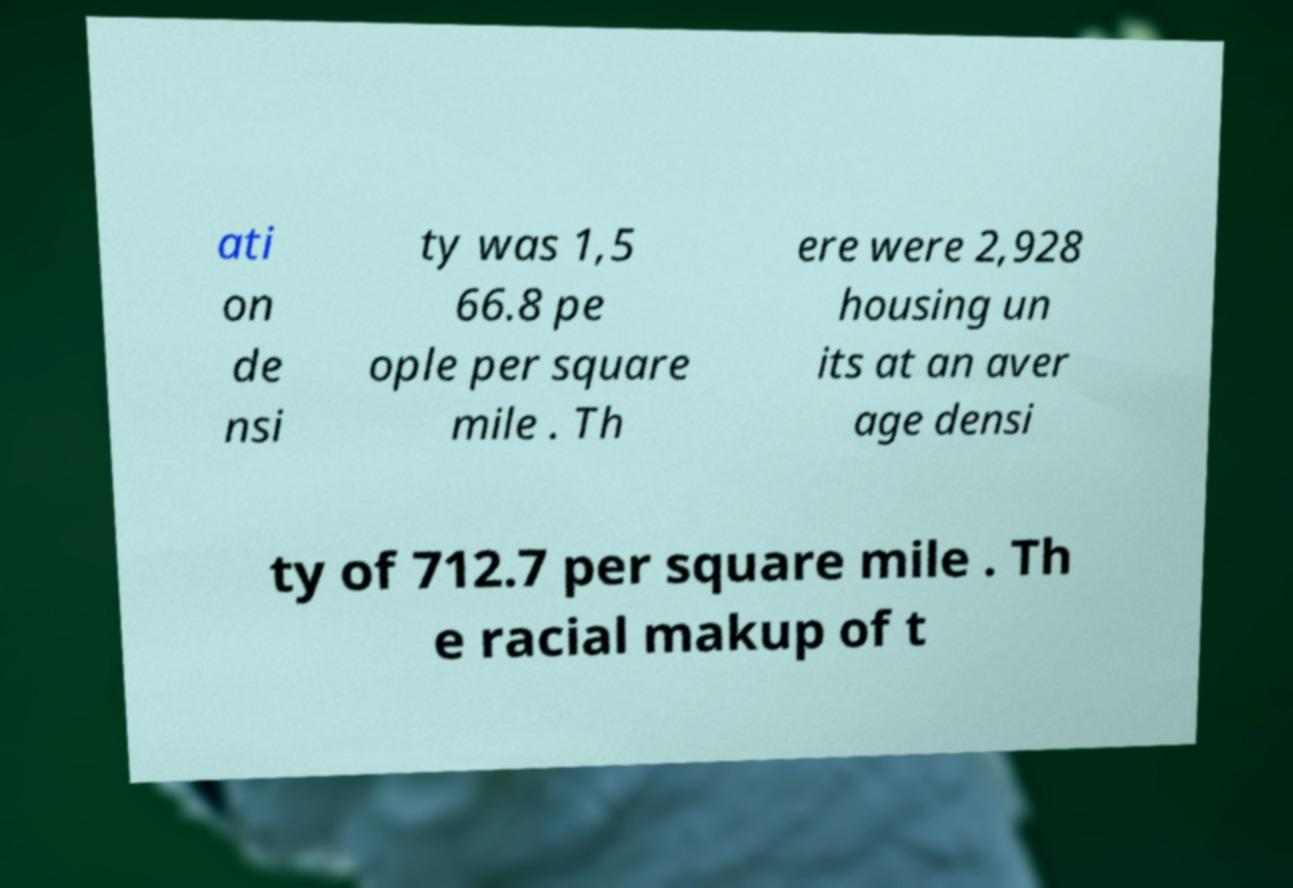Can you accurately transcribe the text from the provided image for me? ati on de nsi ty was 1,5 66.8 pe ople per square mile . Th ere were 2,928 housing un its at an aver age densi ty of 712.7 per square mile . Th e racial makup of t 